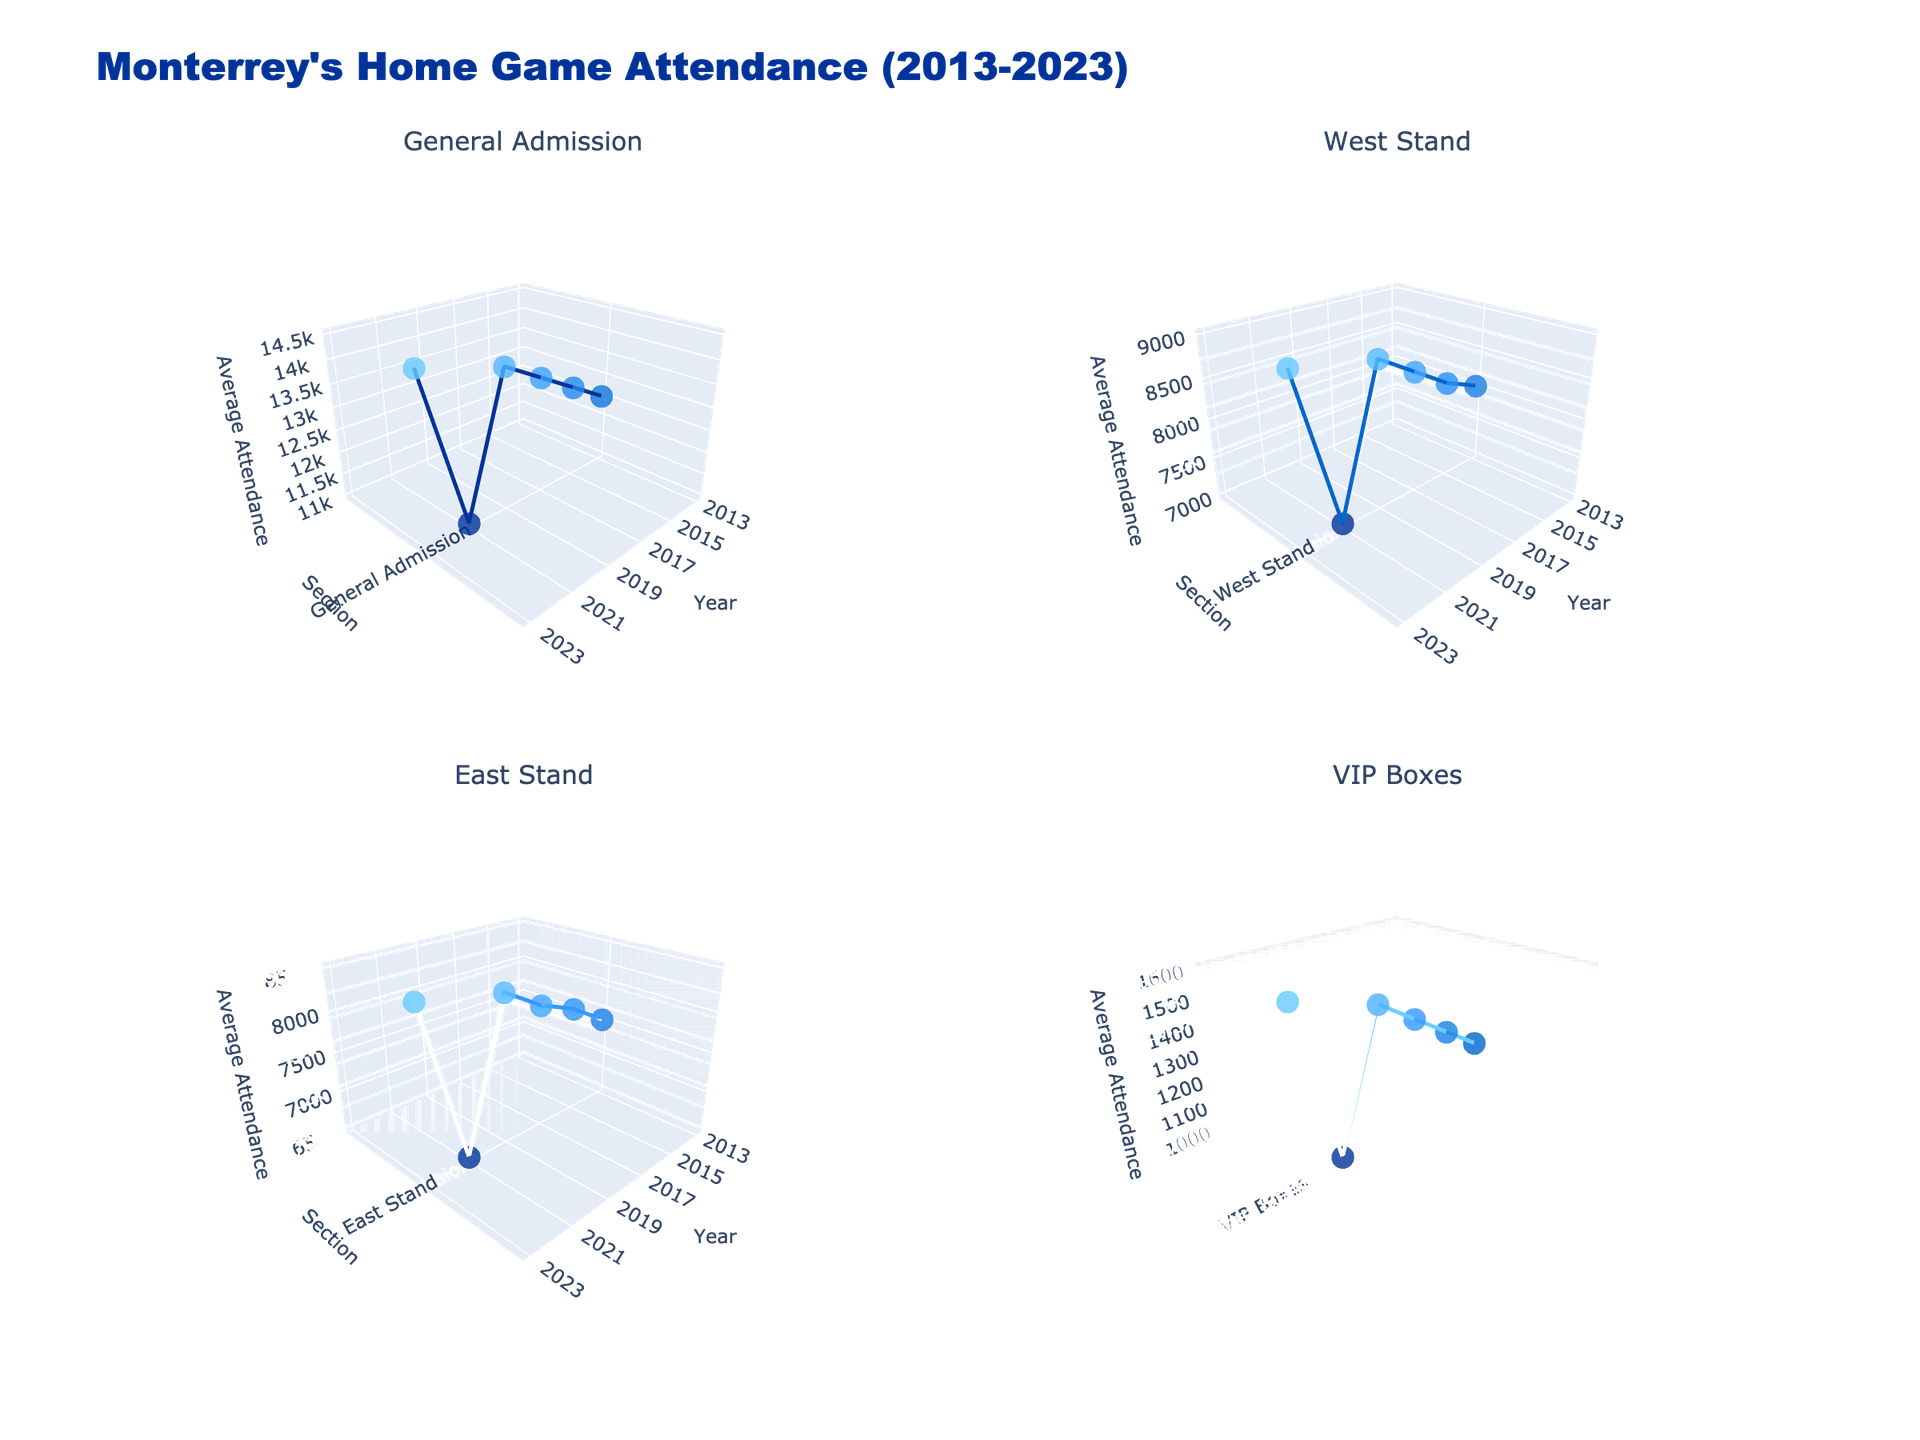What's the title of the figure? The title is usually at the top of the figure in larger and bolder text. In this case, we see "Monterrey's Home Game Attendance (2013-2023)" as the title which provides an overview of what the figure is about.
Answer: Monterrey's Home Game Attendance (2013-2023) What are the axes labeled in each subplot? In each subplot, the axes are labeled x-axis as "Year", y-axis as "Section", and z-axis as "Average Attendance". These labels are consistent across all subplots.
Answer: Year, Section, Average Attendance How has the average attendance in General Admission changed from 2013 to 2023? We look at the data points from the General Admission subplot. Starting from the Year 2013, the average attendance is around 12,500 and gradually increases over the years, peaking at 14,500 in 2023.
Answer: Increased from 12,500 to 14,500 Which section has the lowest average attendance in 2021? By examining the data points and their positions in the year 2021 across all subplots, we see that the lowest value is in the VIP Boxes section, which has an average attendance of 1,000.
Answer: VIP Boxes From 2013 to 2023, which section has shown the most consistent attendance? By viewing the trend lines in all subplots, General Admission shows a relatively consistent and steady increase without any major drops or peaks compared to the other sections.
Answer: General Admission What is the average of the average attendance in the West Stand over the entire period? To calculate this, add the average attendance values for the West Stand from each year available (8,000 + 8,200 + 8,500 + 8,800 + 7,000 + 9,000) and divide by the number of values (6). This gives us (8,000 + 8,200 + 8,500 + 8,800 + 7,000 + 9,000)/6 = 8,250.
Answer: 8,250 Did the average attendance in the East Stand ever surpass that of the General Admission in any year? By comparing the trends for both sections year by year, it's clear that in every year, the General Admission has higher attendance figures compared to the East Stand.
Answer: No Which year showed the most significant drop in average attendance across all sections? Observing all the subplots and comparing year-on-year changes, we see 2021 having a noticeable drop across each section which aligns with a significant decline in attendance figures across the board.
Answer: 2021 What was the average attendance in the VIP Boxes in 2019? Look at the data point for the VIP Boxes subplot for the year 2019 which shows the average attendance value of 1,500.
Answer: 1,500 In which section is the variance in attendance highest from 2013 to 2023? To determine this, we look at the range between the highest and lowest attendance figures for each section. General Admission ranges from 12,500 to 14,500, whereas sections like VIP Boxes vary from 1,000 to 1,600. The largest numerical range is found in General Admission (2,000).
Answer: General Admission 